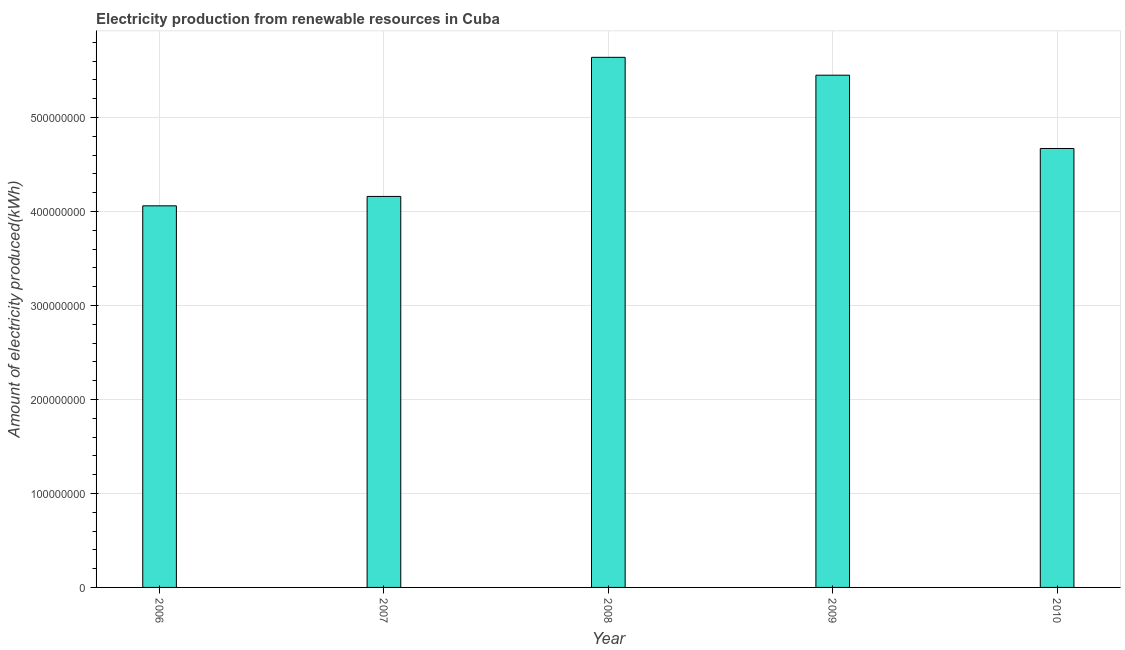What is the title of the graph?
Provide a succinct answer. Electricity production from renewable resources in Cuba. What is the label or title of the X-axis?
Offer a very short reply. Year. What is the label or title of the Y-axis?
Keep it short and to the point. Amount of electricity produced(kWh). What is the amount of electricity produced in 2010?
Your response must be concise. 4.67e+08. Across all years, what is the maximum amount of electricity produced?
Keep it short and to the point. 5.64e+08. Across all years, what is the minimum amount of electricity produced?
Your response must be concise. 4.06e+08. In which year was the amount of electricity produced maximum?
Give a very brief answer. 2008. In which year was the amount of electricity produced minimum?
Make the answer very short. 2006. What is the sum of the amount of electricity produced?
Offer a terse response. 2.40e+09. What is the difference between the amount of electricity produced in 2006 and 2008?
Keep it short and to the point. -1.58e+08. What is the average amount of electricity produced per year?
Provide a short and direct response. 4.80e+08. What is the median amount of electricity produced?
Give a very brief answer. 4.67e+08. Do a majority of the years between 2006 and 2007 (inclusive) have amount of electricity produced greater than 300000000 kWh?
Provide a succinct answer. Yes. What is the ratio of the amount of electricity produced in 2007 to that in 2010?
Keep it short and to the point. 0.89. What is the difference between the highest and the second highest amount of electricity produced?
Keep it short and to the point. 1.90e+07. What is the difference between the highest and the lowest amount of electricity produced?
Your answer should be compact. 1.58e+08. Are all the bars in the graph horizontal?
Your response must be concise. No. How many years are there in the graph?
Give a very brief answer. 5. What is the Amount of electricity produced(kWh) in 2006?
Make the answer very short. 4.06e+08. What is the Amount of electricity produced(kWh) of 2007?
Keep it short and to the point. 4.16e+08. What is the Amount of electricity produced(kWh) in 2008?
Your answer should be very brief. 5.64e+08. What is the Amount of electricity produced(kWh) in 2009?
Keep it short and to the point. 5.45e+08. What is the Amount of electricity produced(kWh) of 2010?
Ensure brevity in your answer.  4.67e+08. What is the difference between the Amount of electricity produced(kWh) in 2006 and 2007?
Provide a short and direct response. -1.00e+07. What is the difference between the Amount of electricity produced(kWh) in 2006 and 2008?
Your answer should be very brief. -1.58e+08. What is the difference between the Amount of electricity produced(kWh) in 2006 and 2009?
Give a very brief answer. -1.39e+08. What is the difference between the Amount of electricity produced(kWh) in 2006 and 2010?
Make the answer very short. -6.10e+07. What is the difference between the Amount of electricity produced(kWh) in 2007 and 2008?
Ensure brevity in your answer.  -1.48e+08. What is the difference between the Amount of electricity produced(kWh) in 2007 and 2009?
Offer a very short reply. -1.29e+08. What is the difference between the Amount of electricity produced(kWh) in 2007 and 2010?
Provide a succinct answer. -5.10e+07. What is the difference between the Amount of electricity produced(kWh) in 2008 and 2009?
Provide a succinct answer. 1.90e+07. What is the difference between the Amount of electricity produced(kWh) in 2008 and 2010?
Ensure brevity in your answer.  9.70e+07. What is the difference between the Amount of electricity produced(kWh) in 2009 and 2010?
Give a very brief answer. 7.80e+07. What is the ratio of the Amount of electricity produced(kWh) in 2006 to that in 2007?
Make the answer very short. 0.98. What is the ratio of the Amount of electricity produced(kWh) in 2006 to that in 2008?
Your answer should be compact. 0.72. What is the ratio of the Amount of electricity produced(kWh) in 2006 to that in 2009?
Your response must be concise. 0.74. What is the ratio of the Amount of electricity produced(kWh) in 2006 to that in 2010?
Ensure brevity in your answer.  0.87. What is the ratio of the Amount of electricity produced(kWh) in 2007 to that in 2008?
Provide a succinct answer. 0.74. What is the ratio of the Amount of electricity produced(kWh) in 2007 to that in 2009?
Make the answer very short. 0.76. What is the ratio of the Amount of electricity produced(kWh) in 2007 to that in 2010?
Your answer should be very brief. 0.89. What is the ratio of the Amount of electricity produced(kWh) in 2008 to that in 2009?
Give a very brief answer. 1.03. What is the ratio of the Amount of electricity produced(kWh) in 2008 to that in 2010?
Provide a short and direct response. 1.21. What is the ratio of the Amount of electricity produced(kWh) in 2009 to that in 2010?
Give a very brief answer. 1.17. 